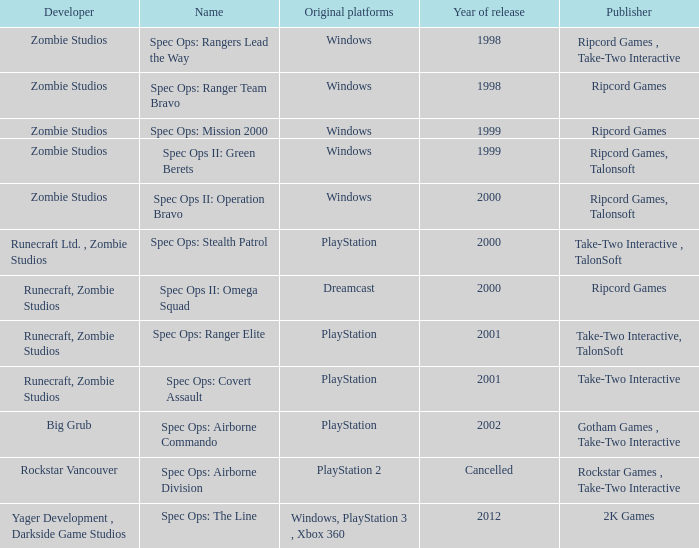Which publisher has release year of 2000 and an original dreamcast platform? Ripcord Games. 